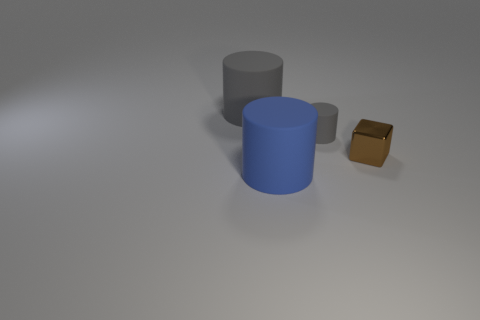Subtract all red cubes. How many gray cylinders are left? 2 Subtract all gray cylinders. How many cylinders are left? 1 Add 3 brown things. How many objects exist? 7 Subtract all purple cylinders. Subtract all green blocks. How many cylinders are left? 3 Subtract all cubes. How many objects are left? 3 Add 3 tiny gray matte things. How many tiny gray matte things are left? 4 Add 3 big purple shiny blocks. How many big purple shiny blocks exist? 3 Subtract 0 gray blocks. How many objects are left? 4 Subtract all gray rubber objects. Subtract all gray matte cylinders. How many objects are left? 0 